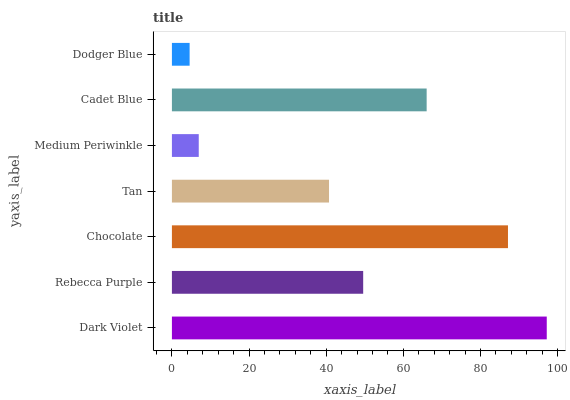Is Dodger Blue the minimum?
Answer yes or no. Yes. Is Dark Violet the maximum?
Answer yes or no. Yes. Is Rebecca Purple the minimum?
Answer yes or no. No. Is Rebecca Purple the maximum?
Answer yes or no. No. Is Dark Violet greater than Rebecca Purple?
Answer yes or no. Yes. Is Rebecca Purple less than Dark Violet?
Answer yes or no. Yes. Is Rebecca Purple greater than Dark Violet?
Answer yes or no. No. Is Dark Violet less than Rebecca Purple?
Answer yes or no. No. Is Rebecca Purple the high median?
Answer yes or no. Yes. Is Rebecca Purple the low median?
Answer yes or no. Yes. Is Cadet Blue the high median?
Answer yes or no. No. Is Dodger Blue the low median?
Answer yes or no. No. 